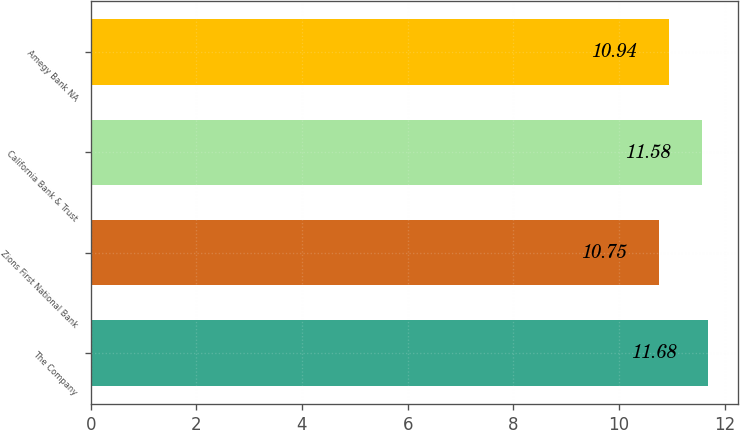Convert chart to OTSL. <chart><loc_0><loc_0><loc_500><loc_500><bar_chart><fcel>The Company<fcel>Zions First National Bank<fcel>California Bank & Trust<fcel>Amegy Bank NA<nl><fcel>11.68<fcel>10.75<fcel>11.58<fcel>10.94<nl></chart> 